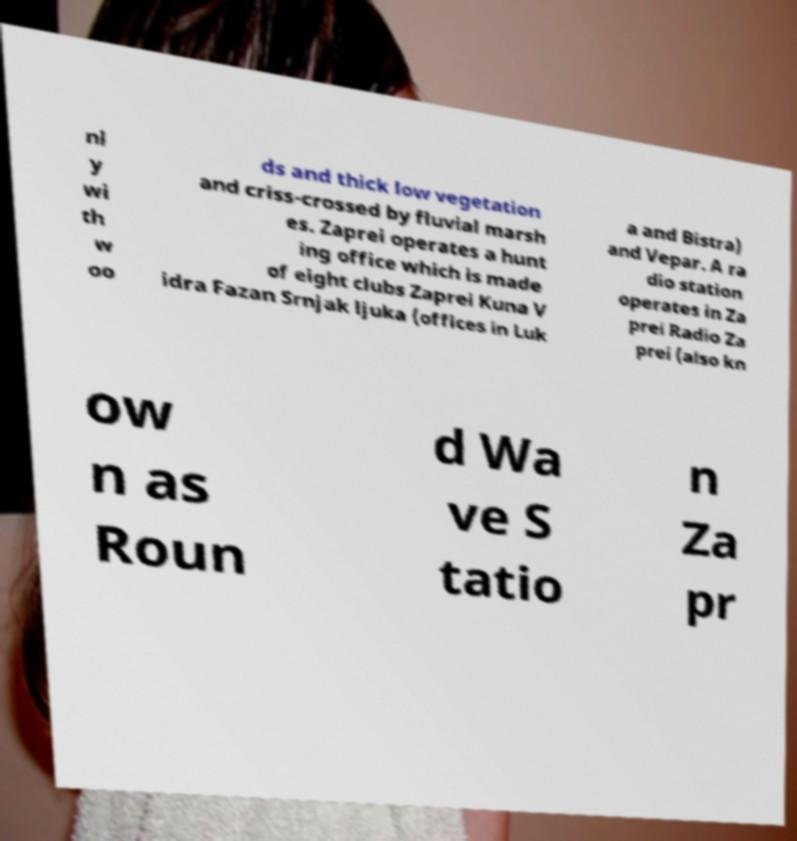For documentation purposes, I need the text within this image transcribed. Could you provide that? nl y wi th w oo ds and thick low vegetation and criss-crossed by fluvial marsh es. Zaprei operates a hunt ing office which is made of eight clubs Zaprei Kuna V idra Fazan Srnjak ljuka (offices in Luk a and Bistra) and Vepar. A ra dio station operates in Za prei Radio Za prei (also kn ow n as Roun d Wa ve S tatio n Za pr 